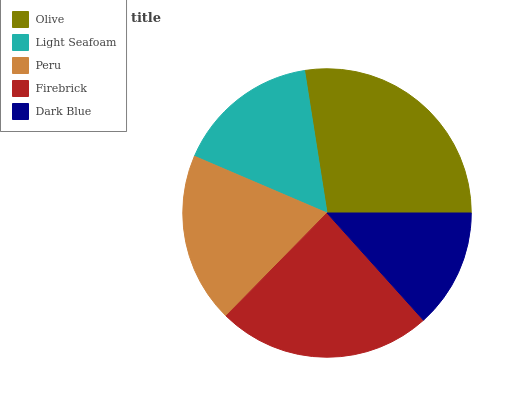Is Dark Blue the minimum?
Answer yes or no. Yes. Is Olive the maximum?
Answer yes or no. Yes. Is Light Seafoam the minimum?
Answer yes or no. No. Is Light Seafoam the maximum?
Answer yes or no. No. Is Olive greater than Light Seafoam?
Answer yes or no. Yes. Is Light Seafoam less than Olive?
Answer yes or no. Yes. Is Light Seafoam greater than Olive?
Answer yes or no. No. Is Olive less than Light Seafoam?
Answer yes or no. No. Is Peru the high median?
Answer yes or no. Yes. Is Peru the low median?
Answer yes or no. Yes. Is Olive the high median?
Answer yes or no. No. Is Light Seafoam the low median?
Answer yes or no. No. 